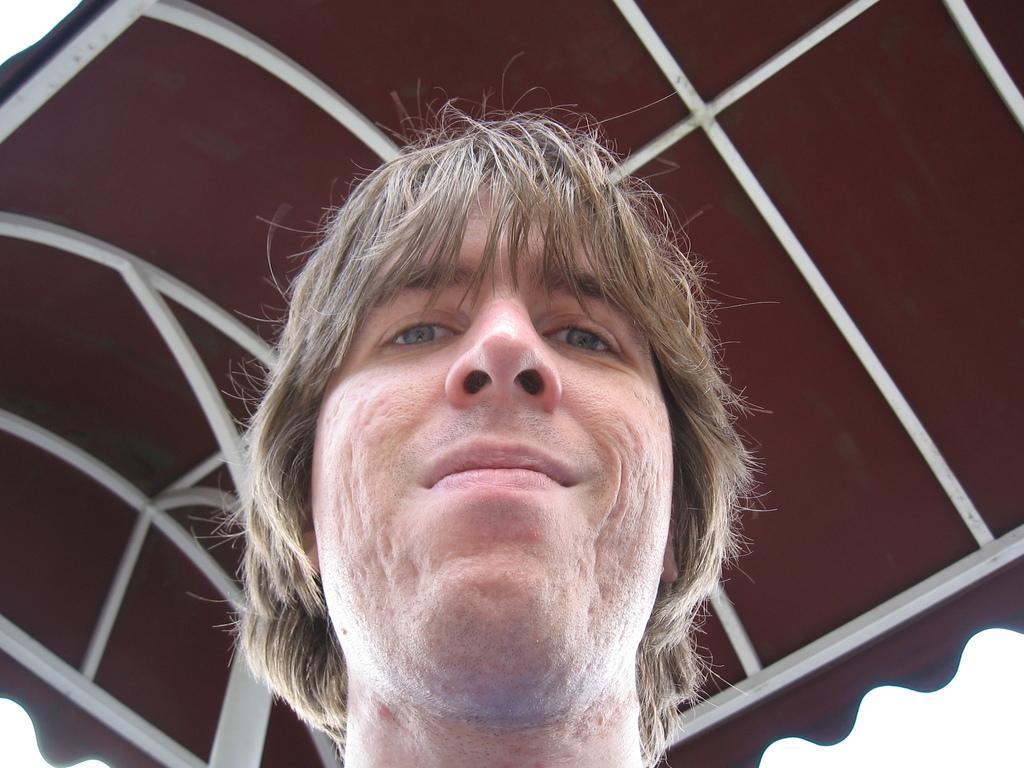Please provide a concise description of this image. In this image we can see a person's face and top of the image there is roof. 